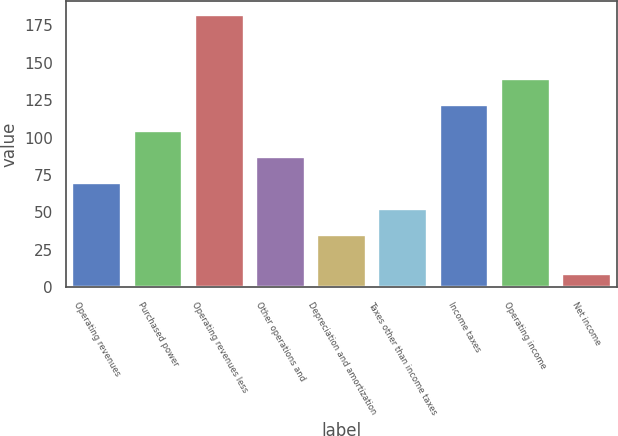Convert chart to OTSL. <chart><loc_0><loc_0><loc_500><loc_500><bar_chart><fcel>Operating revenues<fcel>Purchased power<fcel>Operating revenues less<fcel>Other operations and<fcel>Depreciation and amortization<fcel>Taxes other than income taxes<fcel>Income taxes<fcel>Operating income<fcel>Net income<nl><fcel>69.6<fcel>104.2<fcel>182<fcel>86.9<fcel>35<fcel>52.3<fcel>121.5<fcel>138.8<fcel>9<nl></chart> 